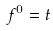<formula> <loc_0><loc_0><loc_500><loc_500>f ^ { 0 } = t</formula> 